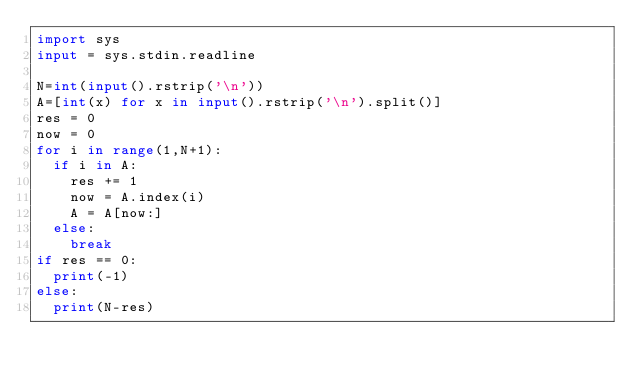<code> <loc_0><loc_0><loc_500><loc_500><_Python_>import sys
input = sys.stdin.readline

N=int(input().rstrip('\n'))
A=[int(x) for x in input().rstrip('\n').split()]
res = 0
now = 0
for i in range(1,N+1):
  if i in A:
    res += 1
    now = A.index(i)
    A = A[now:]
  else:
    break
if res == 0:
  print(-1)
else:
  print(N-res)</code> 